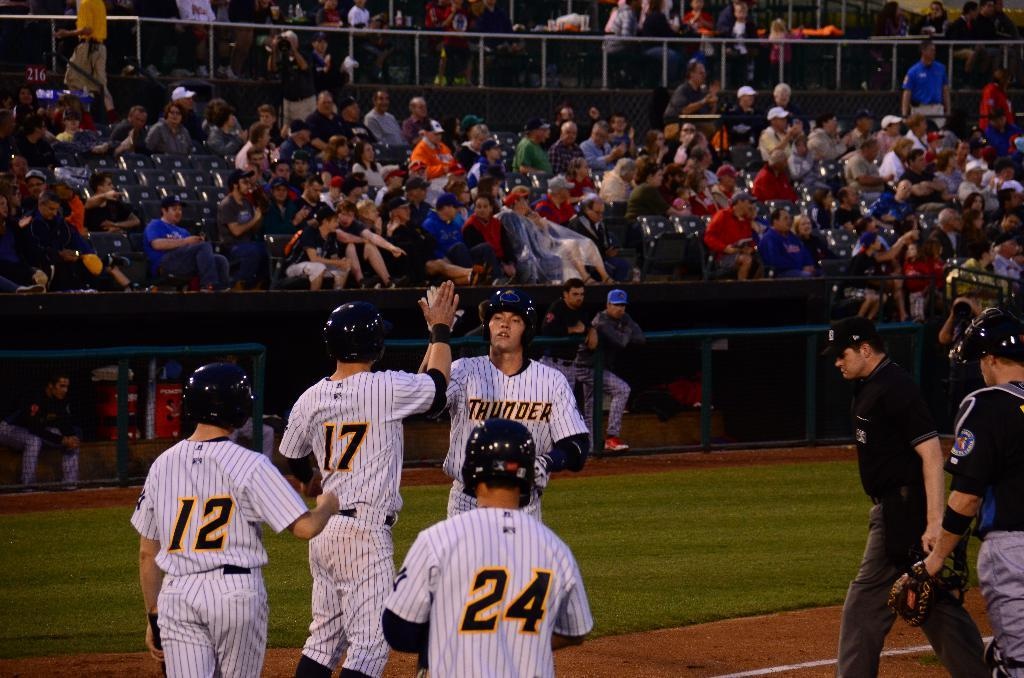<image>
Summarize the visual content of the image. Members of the baseball team Thunder compliment and congratulate one another as fans watch from the stands. 